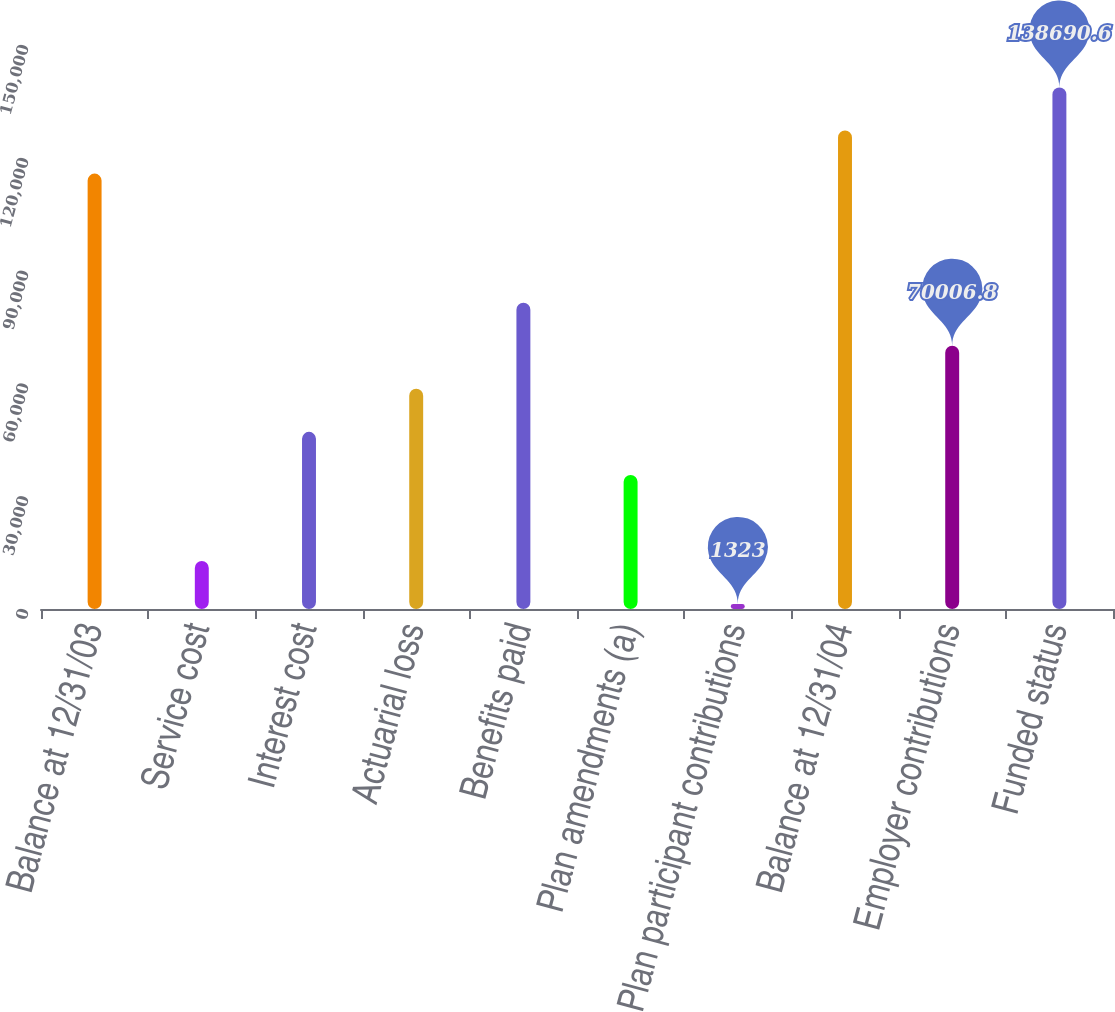Convert chart to OTSL. <chart><loc_0><loc_0><loc_500><loc_500><bar_chart><fcel>Balance at 12/31/03<fcel>Service cost<fcel>Interest cost<fcel>Actuarial loss<fcel>Benefits paid<fcel>Plan amendments (a)<fcel>Plan participant contributions<fcel>Balance at 12/31/04<fcel>Employer contributions<fcel>Funded status<nl><fcel>115796<fcel>12770.3<fcel>47112.2<fcel>58559.5<fcel>81454.1<fcel>35664.9<fcel>1323<fcel>127243<fcel>70006.8<fcel>138691<nl></chart> 